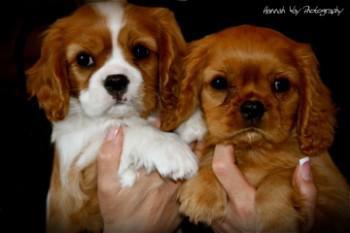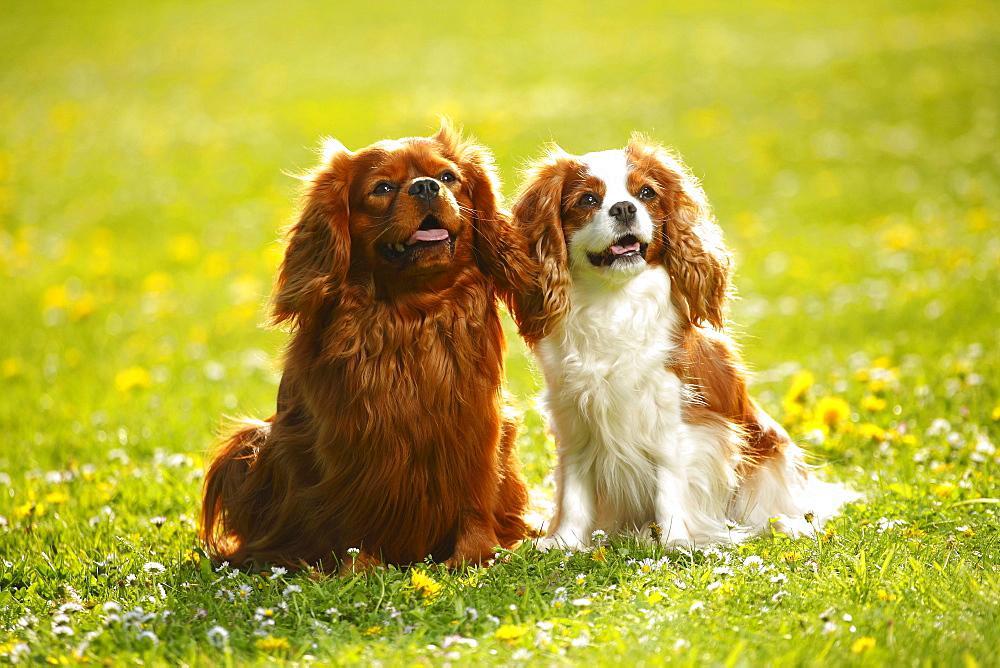The first image is the image on the left, the second image is the image on the right. For the images displayed, is the sentence "Two puppies are being held by human hands." factually correct? Answer yes or no. Yes. 